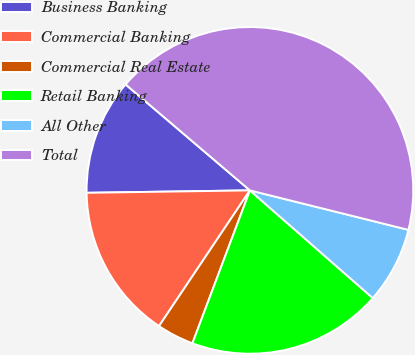Convert chart to OTSL. <chart><loc_0><loc_0><loc_500><loc_500><pie_chart><fcel>Business Banking<fcel>Commercial Banking<fcel>Commercial Real Estate<fcel>Retail Banking<fcel>All Other<fcel>Total<nl><fcel>11.47%<fcel>15.37%<fcel>3.67%<fcel>19.27%<fcel>7.57%<fcel>42.66%<nl></chart> 